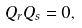Convert formula to latex. <formula><loc_0><loc_0><loc_500><loc_500>Q _ { r } Q _ { s } = 0 ,</formula> 